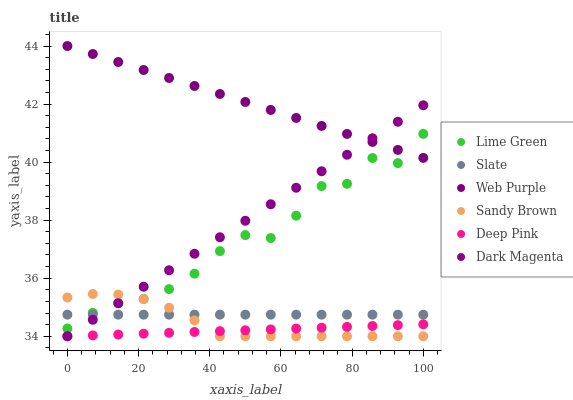Does Deep Pink have the minimum area under the curve?
Answer yes or no. Yes. Does Web Purple have the maximum area under the curve?
Answer yes or no. Yes. Does Dark Magenta have the minimum area under the curve?
Answer yes or no. No. Does Dark Magenta have the maximum area under the curve?
Answer yes or no. No. Is Deep Pink the smoothest?
Answer yes or no. Yes. Is Lime Green the roughest?
Answer yes or no. Yes. Is Dark Magenta the smoothest?
Answer yes or no. No. Is Dark Magenta the roughest?
Answer yes or no. No. Does Deep Pink have the lowest value?
Answer yes or no. Yes. Does Lime Green have the lowest value?
Answer yes or no. No. Does Web Purple have the highest value?
Answer yes or no. Yes. Does Dark Magenta have the highest value?
Answer yes or no. No. Is Deep Pink less than Lime Green?
Answer yes or no. Yes. Is Web Purple greater than Deep Pink?
Answer yes or no. Yes. Does Dark Magenta intersect Web Purple?
Answer yes or no. Yes. Is Dark Magenta less than Web Purple?
Answer yes or no. No. Is Dark Magenta greater than Web Purple?
Answer yes or no. No. Does Deep Pink intersect Lime Green?
Answer yes or no. No. 